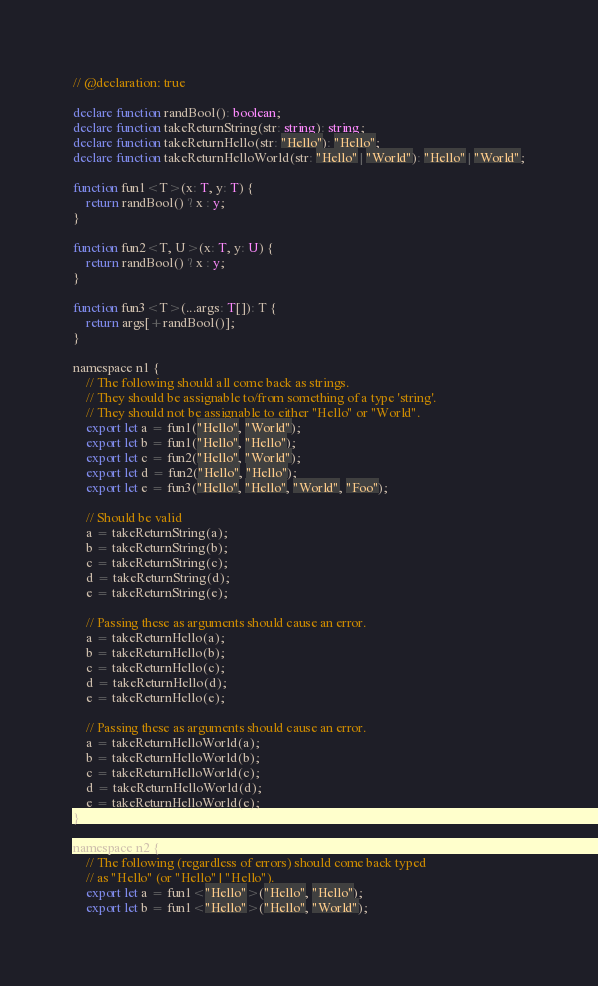Convert code to text. <code><loc_0><loc_0><loc_500><loc_500><_TypeScript_>// @declaration: true

declare function randBool(): boolean;
declare function takeReturnString(str: string): string;
declare function takeReturnHello(str: "Hello"): "Hello";
declare function takeReturnHelloWorld(str: "Hello" | "World"): "Hello" | "World";

function fun1<T>(x: T, y: T) {
    return randBool() ? x : y;
}

function fun2<T, U>(x: T, y: U) {
    return randBool() ? x : y;
}

function fun3<T>(...args: T[]): T {
    return args[+randBool()];
}

namespace n1 {
    // The following should all come back as strings.
    // They should be assignable to/from something of a type 'string'.
    // They should not be assignable to either "Hello" or "World".
    export let a = fun1("Hello", "World");
    export let b = fun1("Hello", "Hello");
    export let c = fun2("Hello", "World");
    export let d = fun2("Hello", "Hello");
    export let e = fun3("Hello", "Hello", "World", "Foo");

    // Should be valid
    a = takeReturnString(a);
    b = takeReturnString(b);
    c = takeReturnString(c);
    d = takeReturnString(d);
    e = takeReturnString(e);
    
    // Passing these as arguments should cause an error.
    a = takeReturnHello(a);
    b = takeReturnHello(b);
    c = takeReturnHello(c);
    d = takeReturnHello(d);
    e = takeReturnHello(e);

    // Passing these as arguments should cause an error.
    a = takeReturnHelloWorld(a);
    b = takeReturnHelloWorld(b);
    c = takeReturnHelloWorld(c);
    d = takeReturnHelloWorld(d);
    e = takeReturnHelloWorld(e);
}

namespace n2 {
    // The following (regardless of errors) should come back typed
    // as "Hello" (or "Hello" | "Hello").
    export let a = fun1<"Hello">("Hello", "Hello");
    export let b = fun1<"Hello">("Hello", "World");</code> 